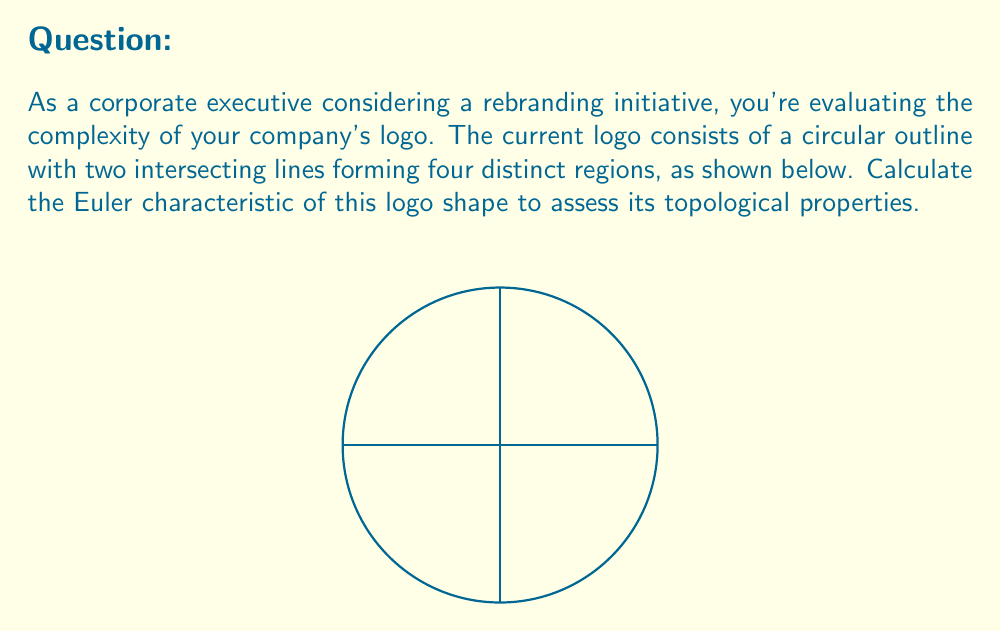Can you answer this question? To calculate the Euler characteristic (χ) of the logo shape, we use the formula:

$$χ = V - E + F$$

Where:
V = number of vertices
E = number of edges
F = number of faces

Step 1: Count the vertices (V)
There are 5 vertices: 4 where the lines intersect the circle, and 1 where the lines intersect each other.
V = 5

Step 2: Count the edges (E)
There are 8 edges: 4 circular arcs and 4 line segments.
E = 8

Step 3: Count the faces (F)
There are 5 faces: 4 regions inside the circle and 1 region outside the circle.
F = 5

Step 4: Apply the Euler characteristic formula
$$χ = V - E + F$$
$$χ = 5 - 8 + 5$$
$$χ = 2$$

The Euler characteristic of 2 indicates that this shape is topologically equivalent to a sphere, which is typical for simple, closed shapes in 2D space.
Answer: $$χ = 2$$ 